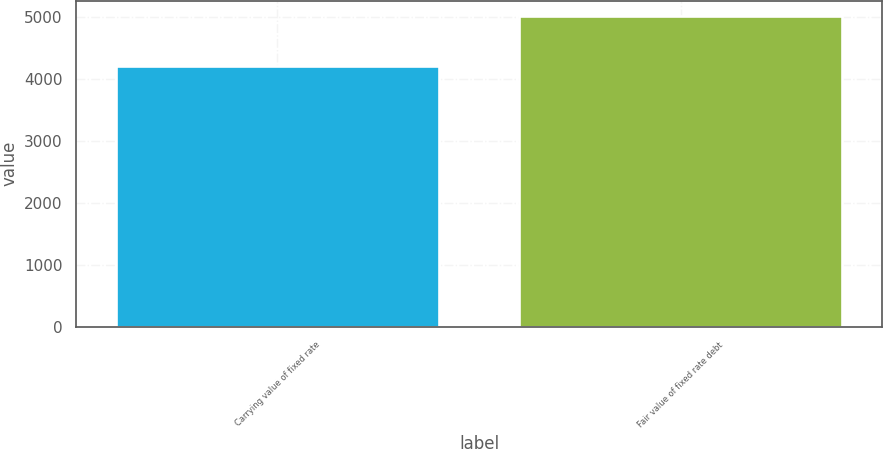Convert chart. <chart><loc_0><loc_0><loc_500><loc_500><bar_chart><fcel>Carrying value of fixed rate<fcel>Fair value of fixed rate debt<nl><fcel>4209<fcel>5016<nl></chart> 